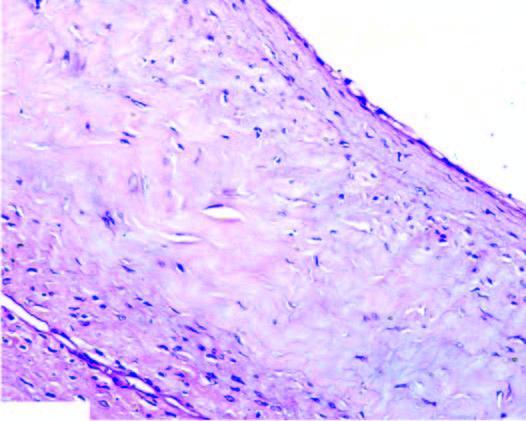what shows myxoid degeneration?
Answer the question using a single word or phrase. Cyst wall 